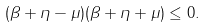<formula> <loc_0><loc_0><loc_500><loc_500>( \beta + \eta - \mu ) ( \beta + \eta + \mu ) \leq 0 .</formula> 